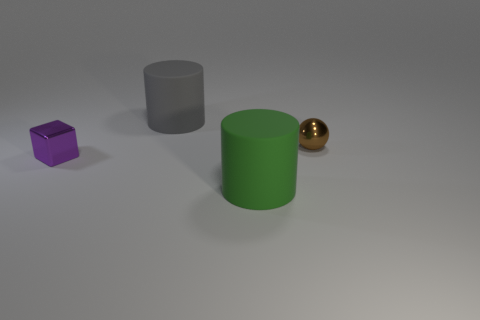What is the size of the thing behind the tiny brown shiny sphere?
Give a very brief answer. Large. The large gray matte object is what shape?
Give a very brief answer. Cylinder. Do the cylinder behind the brown shiny sphere and the rubber cylinder that is in front of the tiny block have the same size?
Offer a very short reply. Yes. There is a cylinder that is in front of the large object that is behind the small thing right of the tiny shiny cube; what size is it?
Your answer should be very brief. Large. What is the shape of the large matte object behind the cylinder right of the matte object behind the brown shiny thing?
Ensure brevity in your answer.  Cylinder. The small thing that is behind the tiny purple block has what shape?
Make the answer very short. Sphere. Do the small brown thing and the big cylinder that is in front of the big gray cylinder have the same material?
Provide a short and direct response. No. How many other objects are the same shape as the purple shiny thing?
Your answer should be compact. 0. There is a tiny cube; is its color the same as the large object that is behind the large green thing?
Keep it short and to the point. No. Are there any other things that are the same material as the small brown thing?
Your answer should be compact. Yes. 